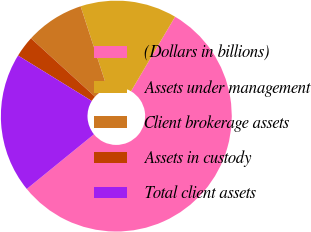Convert chart. <chart><loc_0><loc_0><loc_500><loc_500><pie_chart><fcel>(Dollars in billions)<fcel>Assets under management<fcel>Client brokerage assets<fcel>Assets in custody<fcel>Total client assets<nl><fcel>55.63%<fcel>13.5%<fcel>8.24%<fcel>2.97%<fcel>19.66%<nl></chart> 